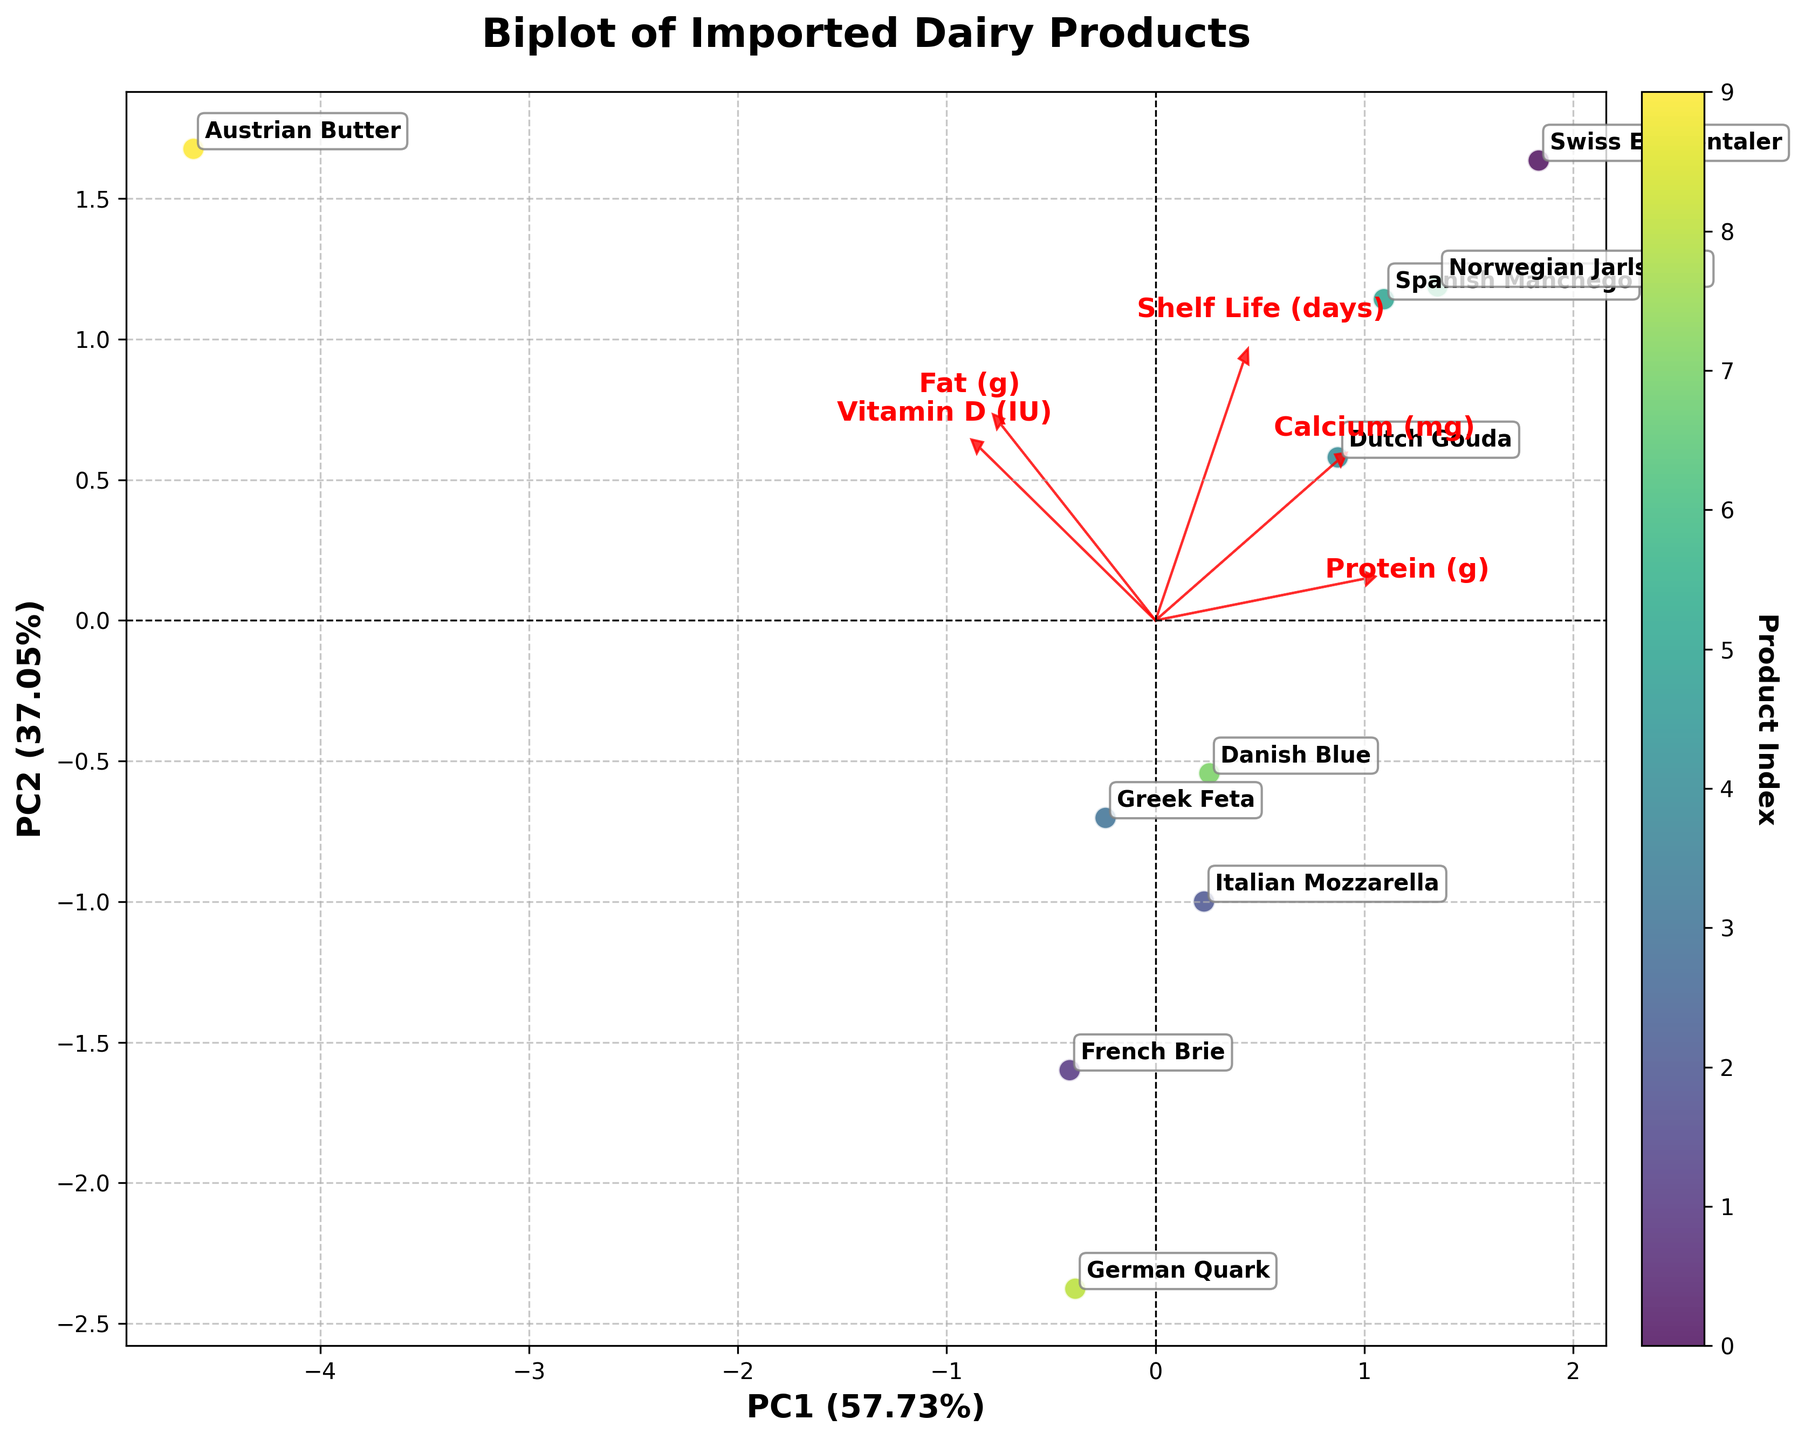What is the title of the plot? The title of the plot is typically located at the top center of the figure. It is in bold and larger font to highlight the main context of the plot. In this case, the title is 'Biplot of Imported Dairy Products,' which is directly indicated at the top of the plot.
Answer: Biplot of Imported Dairy Products How many dairy products are included in the plot? By examining the number of distinct points, each labeled with a different product name, one can count the total number of dairy products displayed in the plot. There are 10 distinct products mentioned in the data.
Answer: 10 What are the axis labels, and what do they represent? The axis labels are usually positioned along the axes and are often in bold. Here, the x-axis label is 'PC1' and the y-axis label is 'PC2'. These represent the first and second principal components, which are the new dimensions obtained after applying Principal Component Analysis (PCA) to the standardized nutritional and shelf life data.
Answer: PC1 and PC2 Which product has the highest value in Fat (g) as represented in the plot? The product with the highest value in Fat (g) would be associated with a loading arrow indicating a higher fat content. By comparing the positions and annotations of the products relative to the 'Fat (g)' loading vector, 'Austrian Butter' stands out as it has the highest fat content with 81g.
Answer: Austrian Butter What percentage of the total variance is explained by PC1 and PC2 together? The percentage of the total variance explained by PC1 and PC2 is generally shown in parentheses next to the axis labels. The explained variance percentages for PC1 and PC2 need to be summed up. If the axis labels indicated that PC1 explains 45.75% and PC2 explains 30.13%, the total would be: 45.75% + 30.13% = 75.88%.
Answer: 75.88% Which product is closest to the origin of the plot? The product closest to the origin (0,0) can be identified by comparing the coordinates of each product's point in the plot. The product with coordinates nearest to (0,0) in both PC1 and PC2 dimensions is identified.
Answer: Greek Feta Which products show the most similarity in their nutritional values and shelf life? Products that are positioned closely together in the plot have similar values. By observing clusters or closely located points, 'Norwegian Jarlsberg' and 'Dutch Gouda', which are positioned near each other on the plot, indicate similarity.
Answer: Norwegian Jarlsberg and Dutch Gouda What can you infer about 'Vitamin D (IU)' in relation to the PCA components from the plot? By investigating the direction and length of the loading vector associated with 'Vitamin D (IU)', the influence of this nutritional factor on the principal components can be inferred. A longer arrow implies a stronger influence, and its direction indicates which principal component it affects more.
Answer: It is substantially influencing PC1 and PC2 